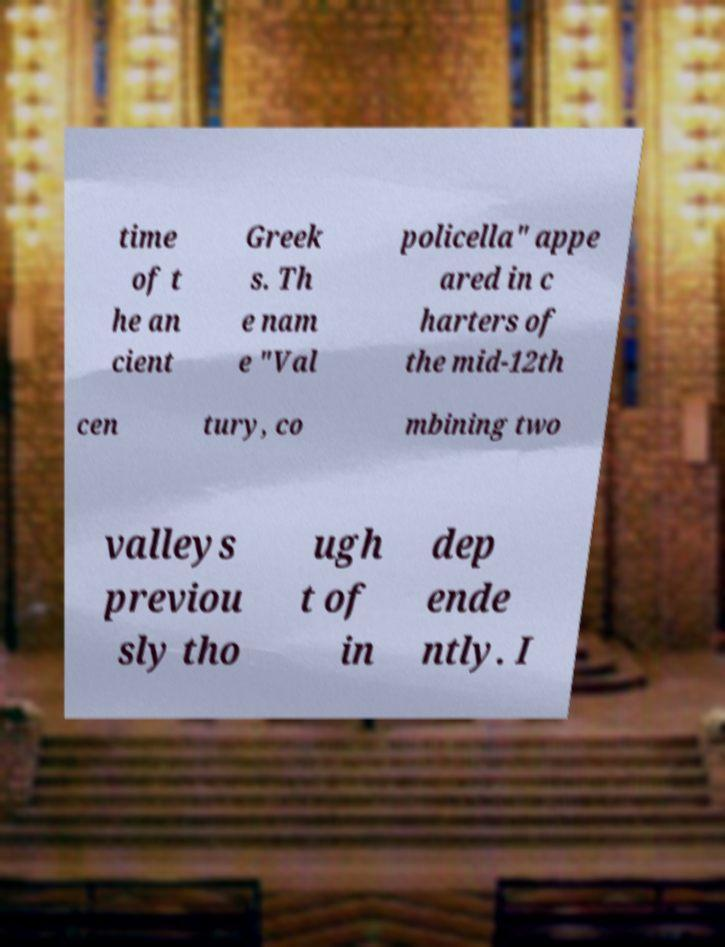I need the written content from this picture converted into text. Can you do that? time of t he an cient Greek s. Th e nam e "Val policella" appe ared in c harters of the mid-12th cen tury, co mbining two valleys previou sly tho ugh t of in dep ende ntly. I 